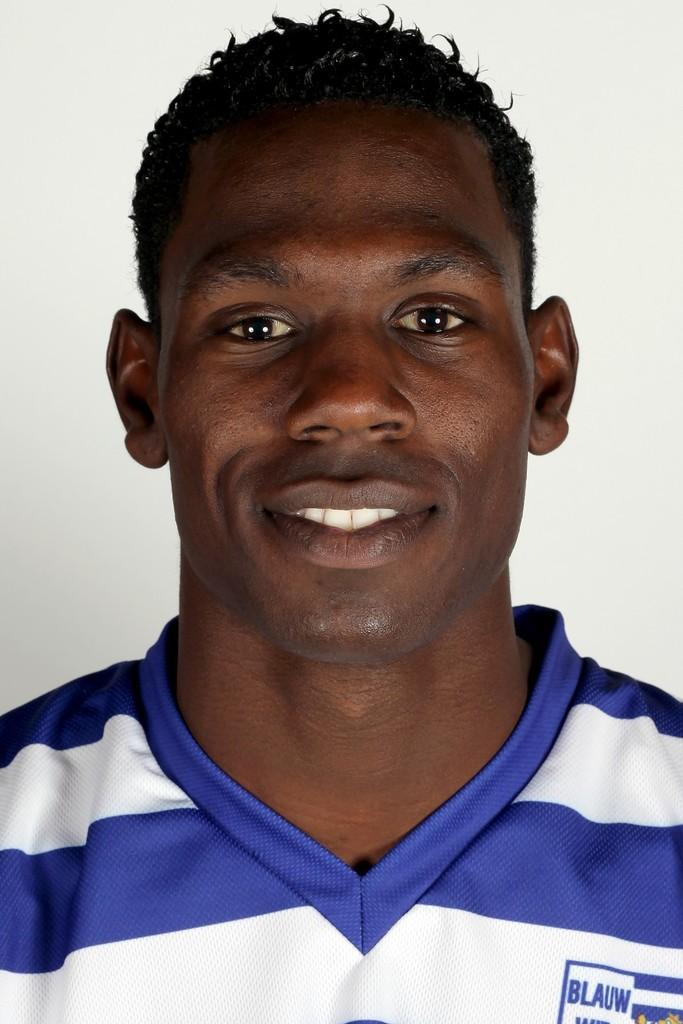What is the main subject of the image? There is a photograph of a man in the image. What color is the background of the image? The background of the image is white. What type of rock is causing trouble in the image? There is no rock present in the image, nor is there any indication of trouble. 